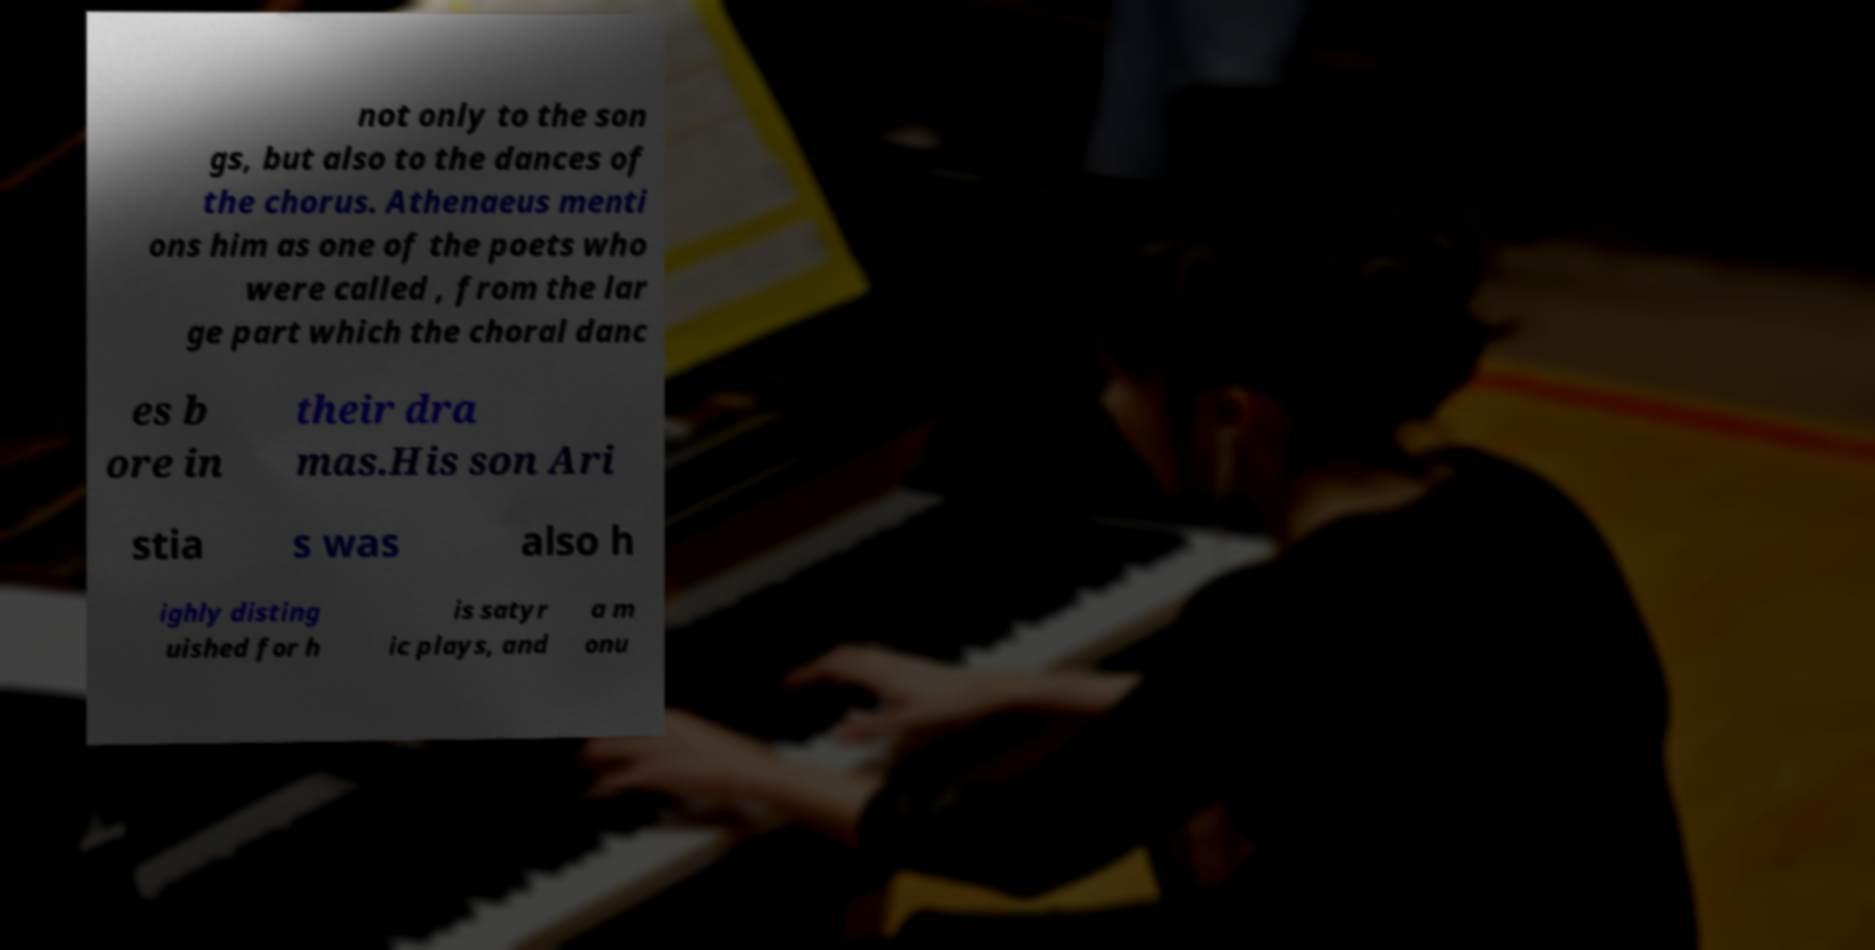Could you assist in decoding the text presented in this image and type it out clearly? not only to the son gs, but also to the dances of the chorus. Athenaeus menti ons him as one of the poets who were called , from the lar ge part which the choral danc es b ore in their dra mas.His son Ari stia s was also h ighly disting uished for h is satyr ic plays, and a m onu 